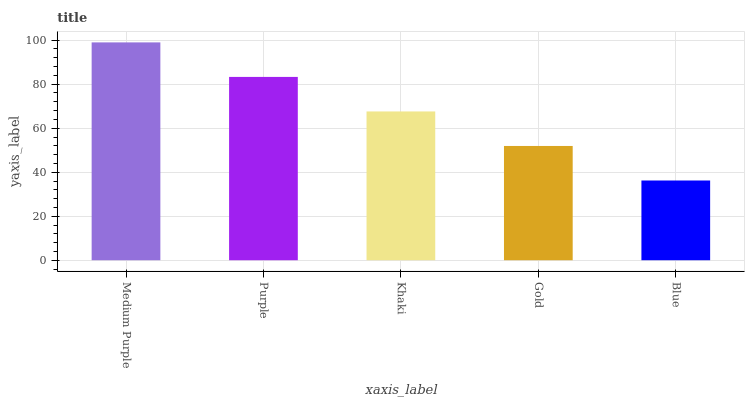Is Blue the minimum?
Answer yes or no. Yes. Is Medium Purple the maximum?
Answer yes or no. Yes. Is Purple the minimum?
Answer yes or no. No. Is Purple the maximum?
Answer yes or no. No. Is Medium Purple greater than Purple?
Answer yes or no. Yes. Is Purple less than Medium Purple?
Answer yes or no. Yes. Is Purple greater than Medium Purple?
Answer yes or no. No. Is Medium Purple less than Purple?
Answer yes or no. No. Is Khaki the high median?
Answer yes or no. Yes. Is Khaki the low median?
Answer yes or no. Yes. Is Blue the high median?
Answer yes or no. No. Is Blue the low median?
Answer yes or no. No. 